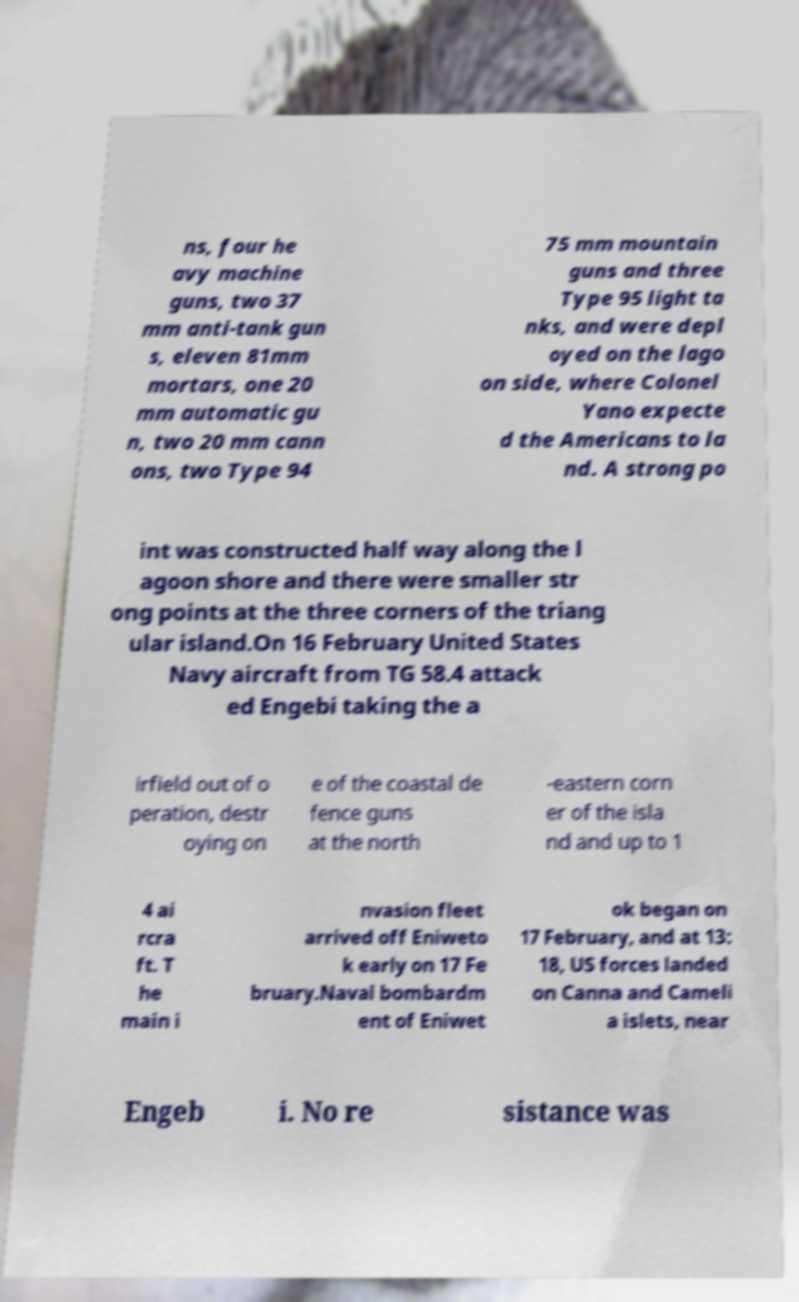What messages or text are displayed in this image? I need them in a readable, typed format. ns, four he avy machine guns, two 37 mm anti-tank gun s, eleven 81mm mortars, one 20 mm automatic gu n, two 20 mm cann ons, two Type 94 75 mm mountain guns and three Type 95 light ta nks, and were depl oyed on the lago on side, where Colonel Yano expecte d the Americans to la nd. A strong po int was constructed half way along the l agoon shore and there were smaller str ong points at the three corners of the triang ular island.On 16 February United States Navy aircraft from TG 58.4 attack ed Engebi taking the a irfield out of o peration, destr oying on e of the coastal de fence guns at the north -eastern corn er of the isla nd and up to 1 4 ai rcra ft. T he main i nvasion fleet arrived off Eniweto k early on 17 Fe bruary.Naval bombardm ent of Eniwet ok began on 17 February, and at 13: 18, US forces landed on Canna and Cameli a islets, near Engeb i. No re sistance was 